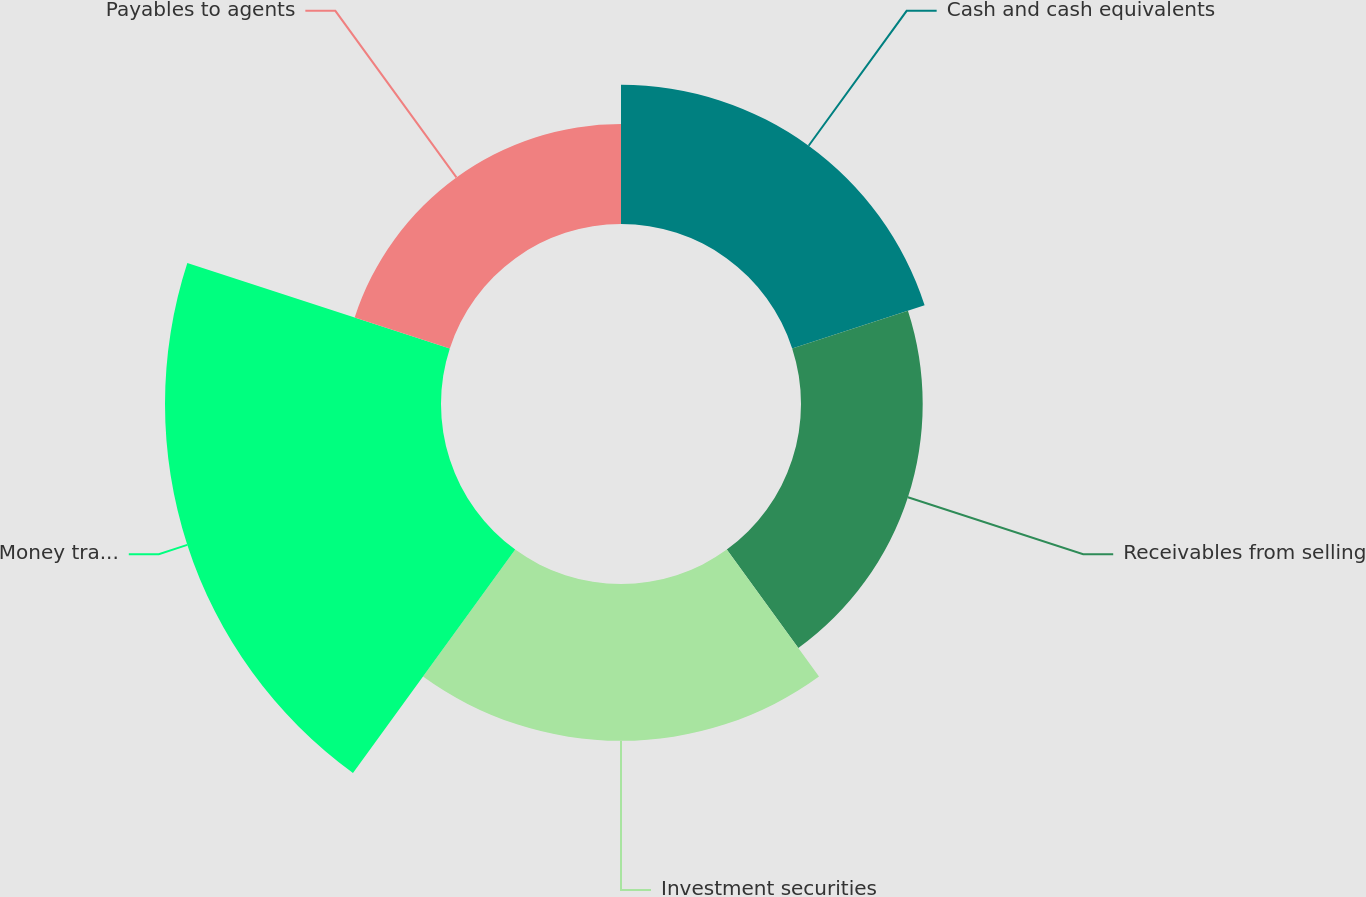Convert chart to OTSL. <chart><loc_0><loc_0><loc_500><loc_500><pie_chart><fcel>Cash and cash equivalents<fcel>Receivables from selling<fcel>Investment securities<fcel>Money transfer money order and<fcel>Payables to agents<nl><fcel>17.54%<fcel>15.33%<fcel>19.76%<fcel>34.77%<fcel>12.6%<nl></chart> 